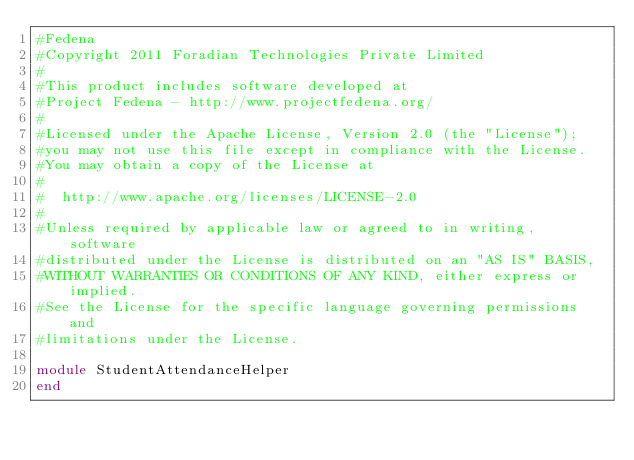<code> <loc_0><loc_0><loc_500><loc_500><_Ruby_>#Fedena
#Copyright 2011 Foradian Technologies Private Limited
#
#This product includes software developed at
#Project Fedena - http://www.projectfedena.org/
#
#Licensed under the Apache License, Version 2.0 (the "License");
#you may not use this file except in compliance with the License.
#You may obtain a copy of the License at
#
#  http://www.apache.org/licenses/LICENSE-2.0
#
#Unless required by applicable law or agreed to in writing, software
#distributed under the License is distributed on an "AS IS" BASIS,
#WITHOUT WARRANTIES OR CONDITIONS OF ANY KIND, either express or implied.
#See the License for the specific language governing permissions and
#limitations under the License.

module StudentAttendanceHelper
end
</code> 